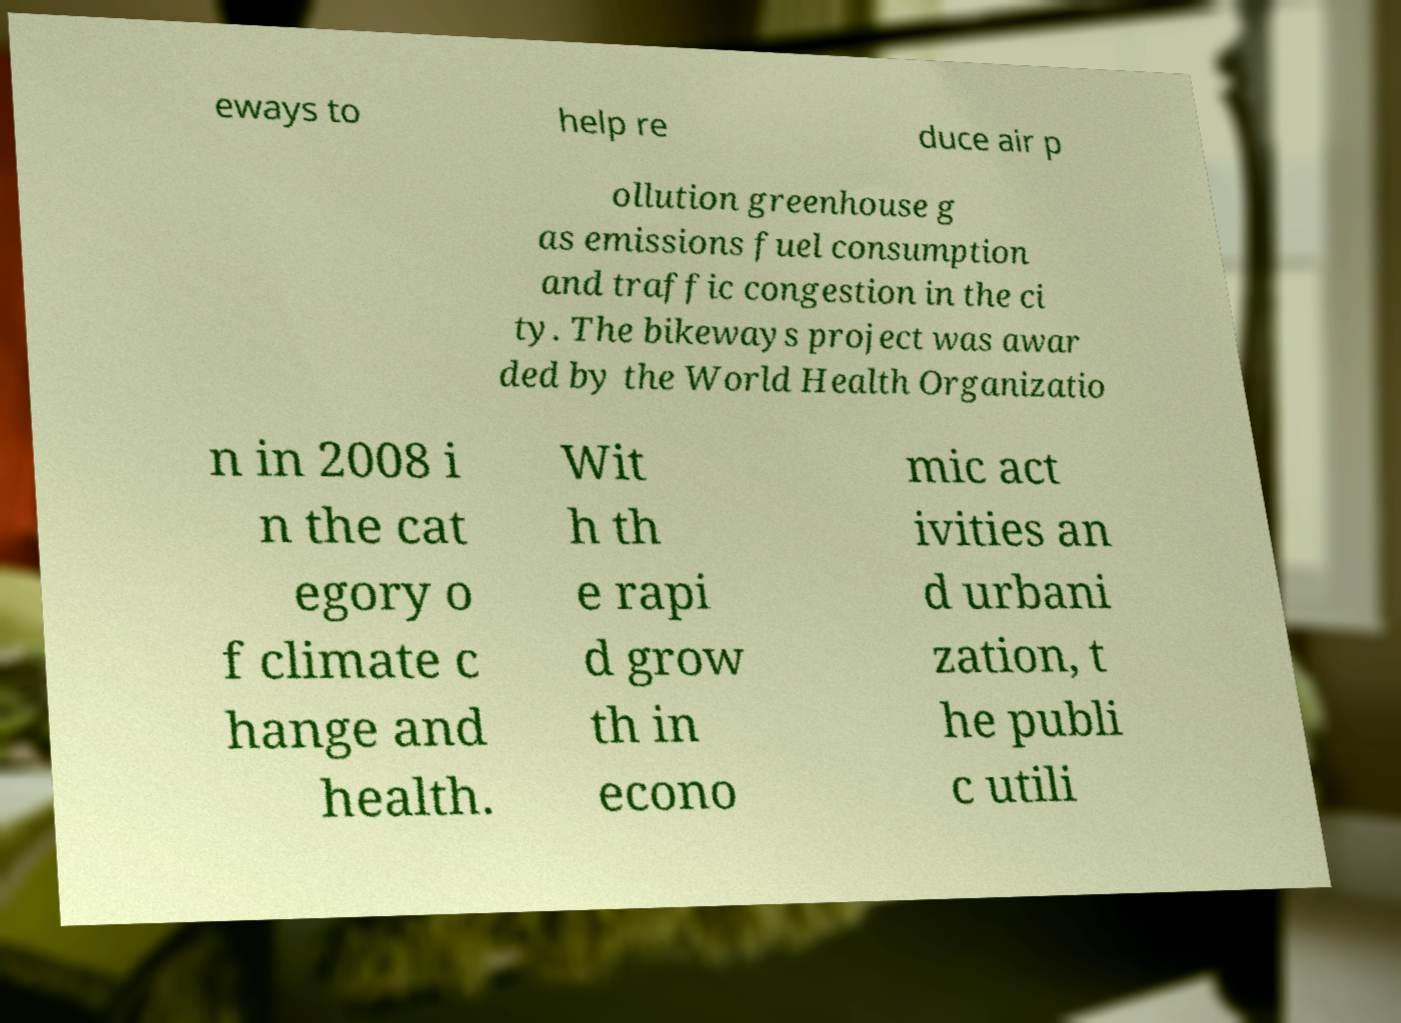I need the written content from this picture converted into text. Can you do that? eways to help re duce air p ollution greenhouse g as emissions fuel consumption and traffic congestion in the ci ty. The bikeways project was awar ded by the World Health Organizatio n in 2008 i n the cat egory o f climate c hange and health. Wit h th e rapi d grow th in econo mic act ivities an d urbani zation, t he publi c utili 